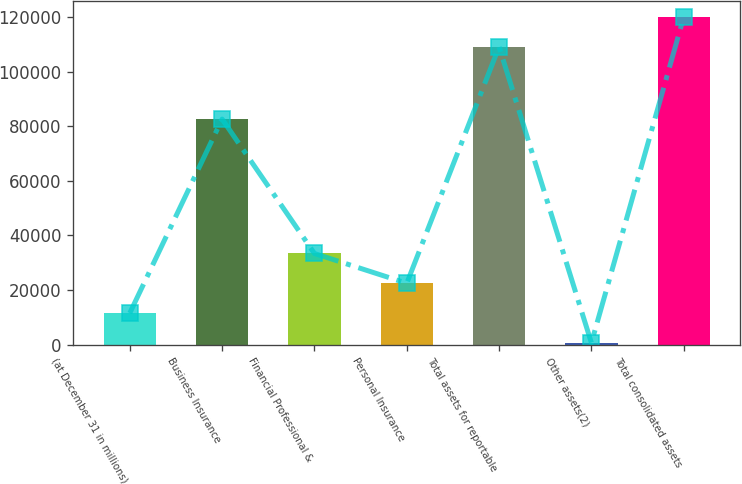Convert chart. <chart><loc_0><loc_0><loc_500><loc_500><bar_chart><fcel>(at December 31 in millions)<fcel>Business Insurance<fcel>Financial Professional &<fcel>Personal Insurance<fcel>Total assets for reportable<fcel>Other assets(2)<fcel>Total consolidated assets<nl><fcel>11534.9<fcel>82622<fcel>33360.7<fcel>22447.8<fcel>109129<fcel>622<fcel>120042<nl></chart> 